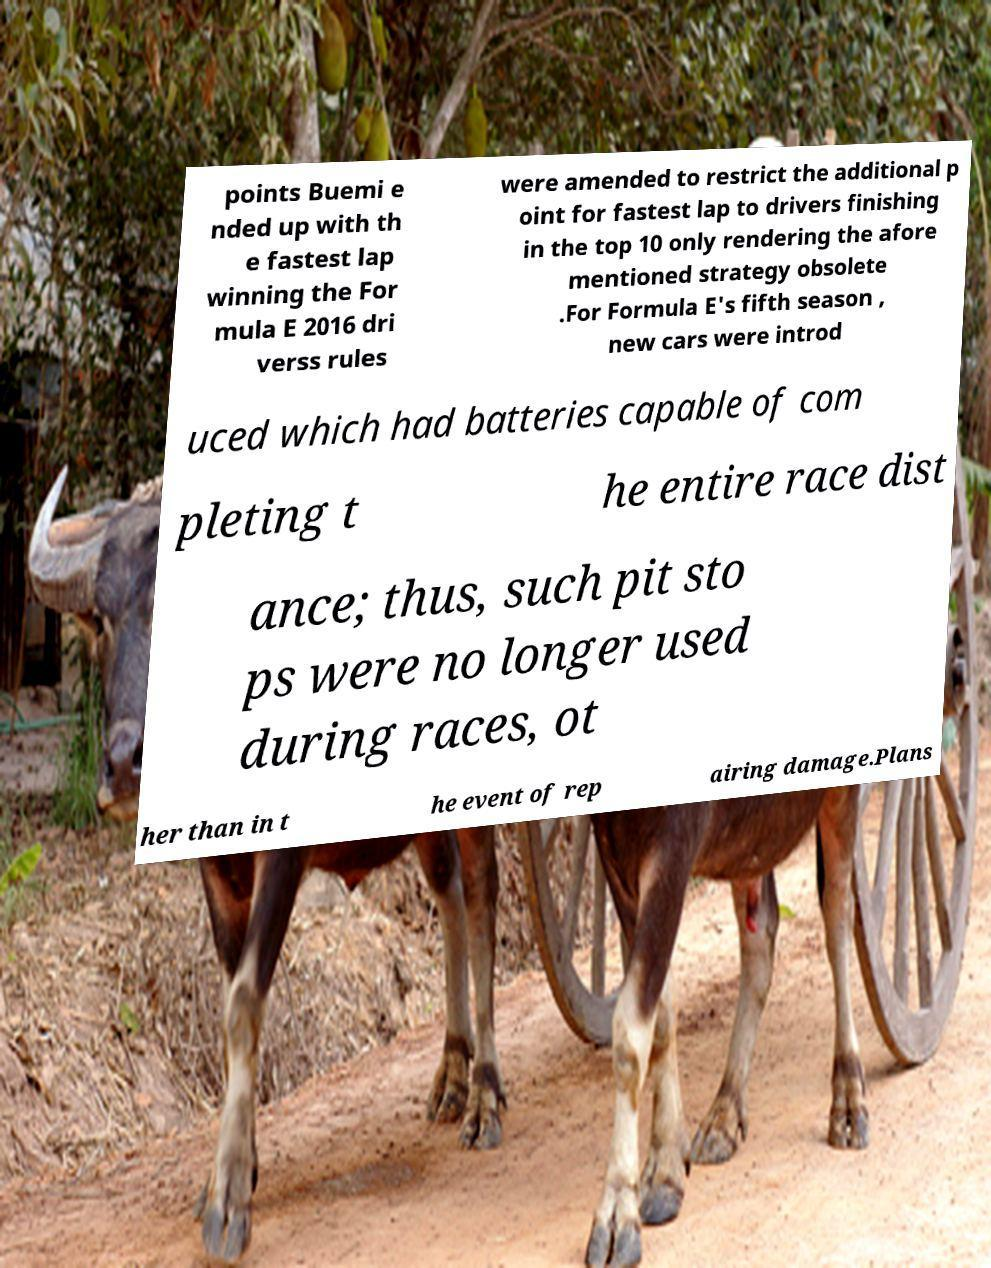I need the written content from this picture converted into text. Can you do that? points Buemi e nded up with th e fastest lap winning the For mula E 2016 dri verss rules were amended to restrict the additional p oint for fastest lap to drivers finishing in the top 10 only rendering the afore mentioned strategy obsolete .For Formula E's fifth season , new cars were introd uced which had batteries capable of com pleting t he entire race dist ance; thus, such pit sto ps were no longer used during races, ot her than in t he event of rep airing damage.Plans 